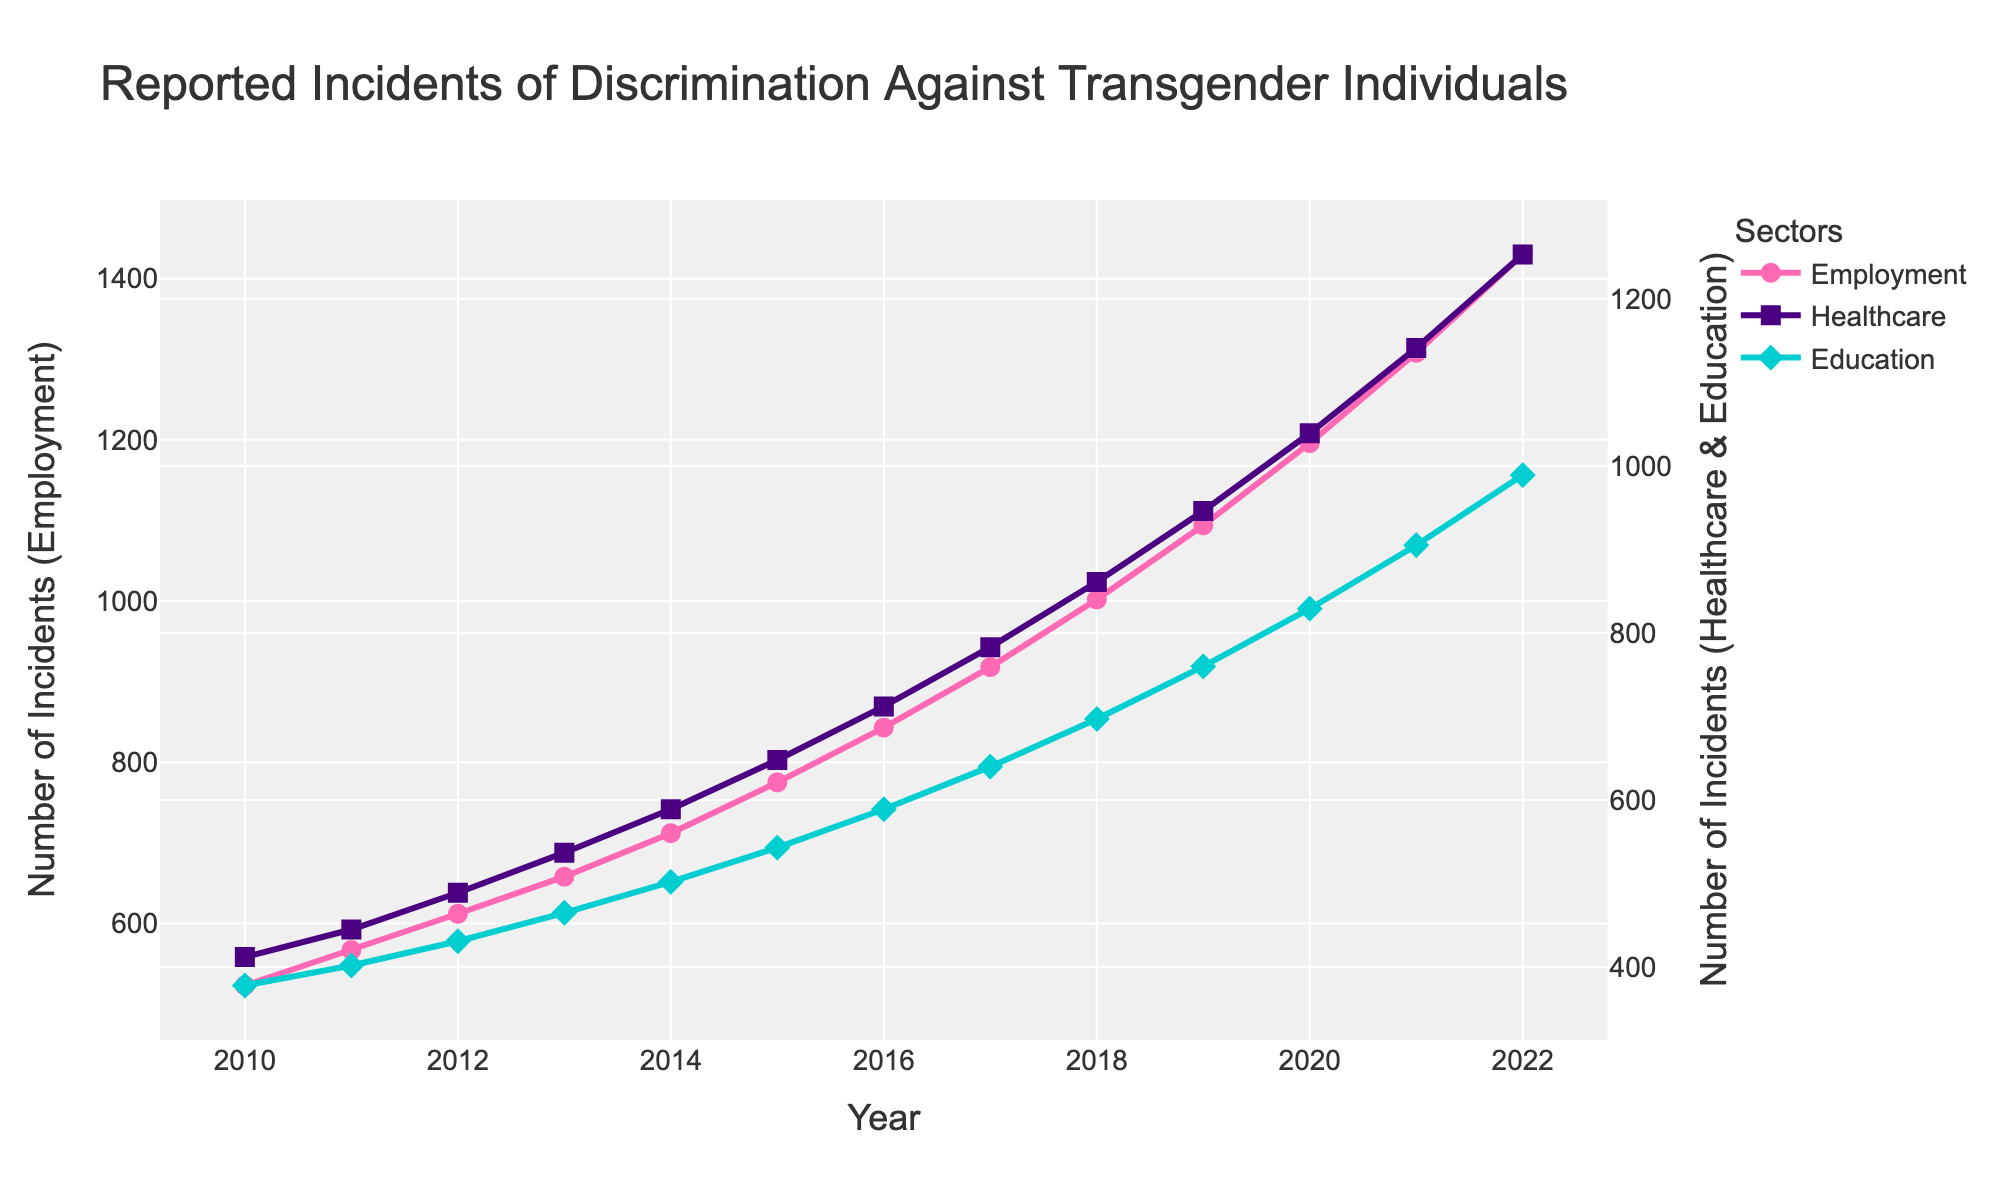What sector had the highest number of reported incidents of discrimination in 2022? Looking at the figure, the line representing Employment shows the highest number of reported incidents compared to Healthcare and Education for the year 2022.
Answer: Employment Between which two consecutive years did the number of reported incidents in Healthcare see the greatest increase? Observing the slope of the line for Healthcare, the steepest increase occurs between 2021 and 2022.
Answer: 2021 and 2022 Which sector consistently had the lowest number of reported incidents every year? By examining all the lines, Education always has the line positioned lowest compared to Employment and Healthcare each year.
Answer: Education How many more reported incidents were there in Employment compared to Healthcare in 2015? The number of reported incidents in Employment in 2015 is 775, and in Healthcare, it's 648. The difference is 775 - 648 = 127.
Answer: 127 What is the average number of reported incidents per year in Education from 2010 to 2022? Summing the incidents in Education for each year from 2010 to 2022 gives 378 + 402 + 431 + 465 + 502 + 543 + 589 + 640 + 697 + 760 + 829 + 905 + 989 = 8530. The average is 8530 / 13 ≈ 656.2.
Answer: 656.2 Which sector showed the most significant relative increase in reported incidents from 2010 to 2022? By comparing the endpoints of each line, Employment starts at 523 and ends at 1430, Healthcare starts at 412 and ends at 1253, Education starts at 378 and ends at 989. Calculating the relative increase: 
Employment: (1430-523)/523 ≈ 1.73 or 173%
Healthcare: (1253-412)/412 ≈ 2.04 or 204%
Education: (989-378)/378 ≈ 1.62 or 162%
Healthcare shows the most significant relative increase of 204%.
Answer: Healthcare What year did the number of reported incidents in Education first exceed 700? The line for Education crosses the 700 mark between 2017 and 2018; specifically, in 2018, it's 697 (just below); in 2019, it's 760, which is above 700. Therefore, the first year that exceeds 700 is 2019.
Answer: 2019 Compare the trend between Employment and Healthcare from 2015 to 2018. What do you observe? From 2015 to 2018, both Employment and Healthcare show an increasing trend. Employment increased from 775 to 1002, and Healthcare increased from 648 to 861, but Healthcare shows a slightly more gradual slope compared to Employment.
Answer: Both increased, but Employment increased more rapidly What is the total number of reported incidents in Employment and Education combined for the year 2020? Adding the reported incidents in Employment (1196) and Education (829) for the year 2020, we get 1196 + 829 = 2025.
Answer: 2025 In which year was the gap between Employment and Education reported incidents the widest? By looking at the vertical distance between the Employment and Education lines year by year, the widest gap is seen in 2022, where Employment is at 1430 and Education is at 989. The gap is 1430 - 989 = 441.
Answer: 2022 